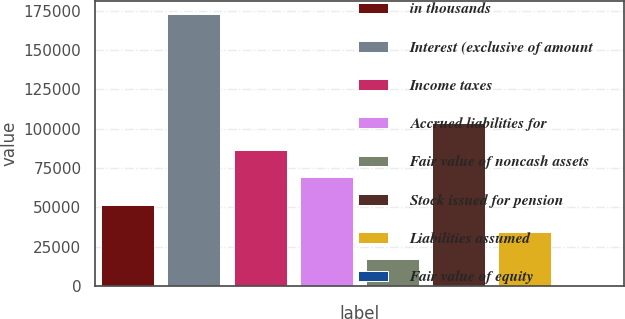Convert chart. <chart><loc_0><loc_0><loc_500><loc_500><bar_chart><fcel>in thousands<fcel>Interest (exclusive of amount<fcel>Income taxes<fcel>Accrued liabilities for<fcel>Fair value of noncash assets<fcel>Stock issued for pension<fcel>Liabilities assumed<fcel>Fair value of equity<nl><fcel>51796.3<fcel>172653<fcel>86326.8<fcel>69061.6<fcel>17265.9<fcel>103592<fcel>34531.1<fcel>0.66<nl></chart> 